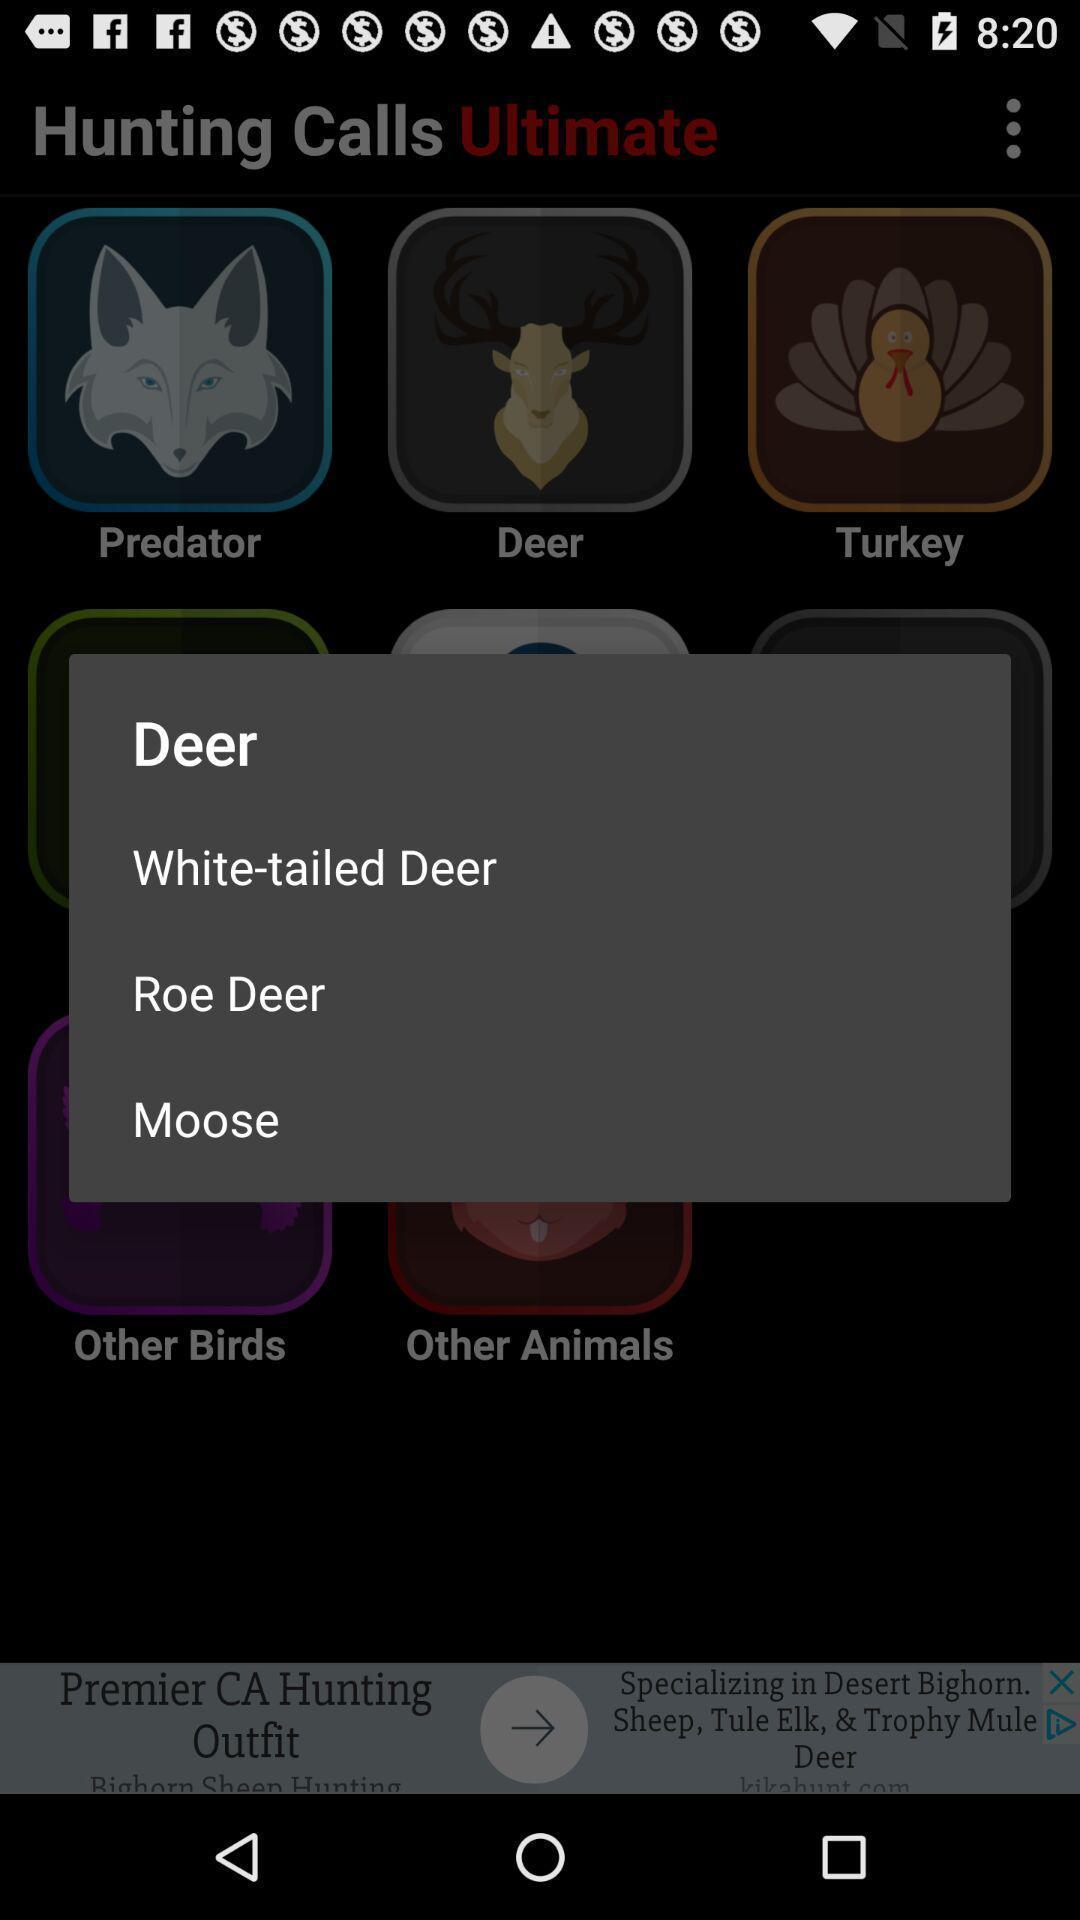Tell me what you see in this picture. Pop-up shows list of deers. 